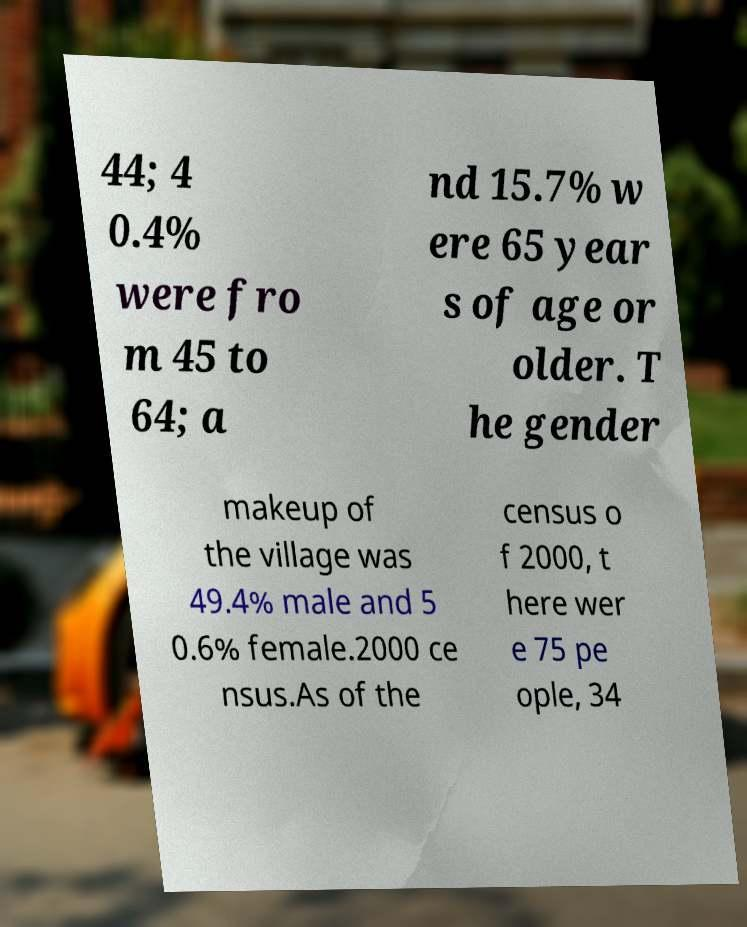Can you accurately transcribe the text from the provided image for me? 44; 4 0.4% were fro m 45 to 64; a nd 15.7% w ere 65 year s of age or older. T he gender makeup of the village was 49.4% male and 5 0.6% female.2000 ce nsus.As of the census o f 2000, t here wer e 75 pe ople, 34 